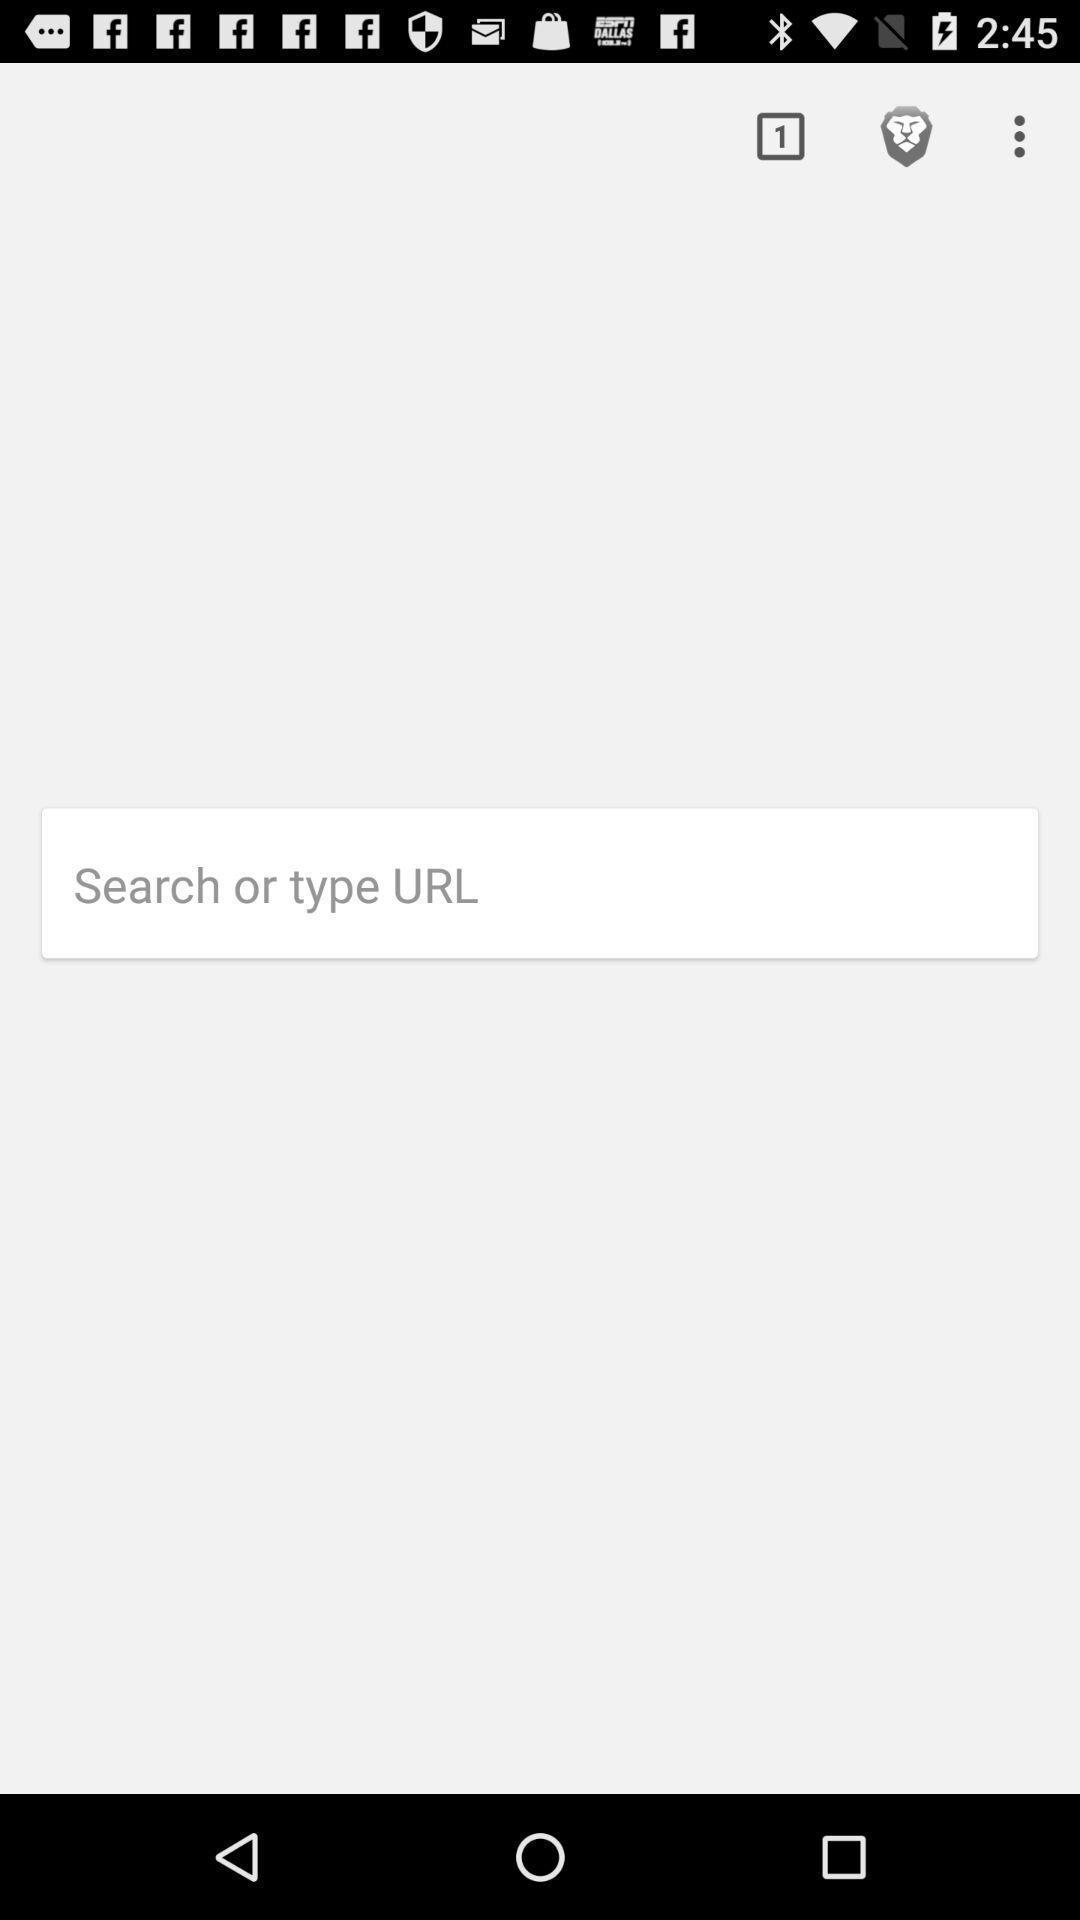Summarize the main components in this picture. Url search box displaying. 